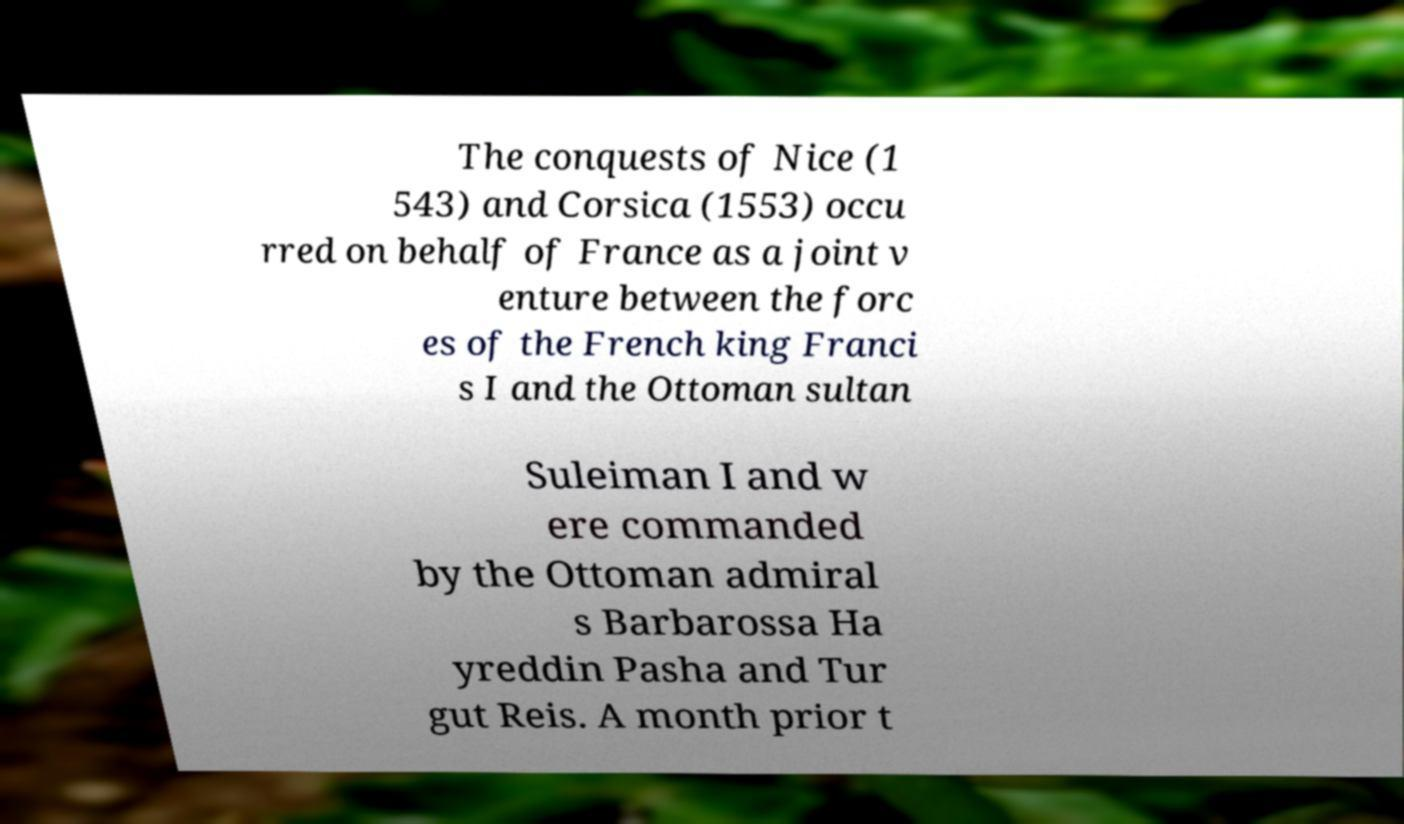For documentation purposes, I need the text within this image transcribed. Could you provide that? The conquests of Nice (1 543) and Corsica (1553) occu rred on behalf of France as a joint v enture between the forc es of the French king Franci s I and the Ottoman sultan Suleiman I and w ere commanded by the Ottoman admiral s Barbarossa Ha yreddin Pasha and Tur gut Reis. A month prior t 